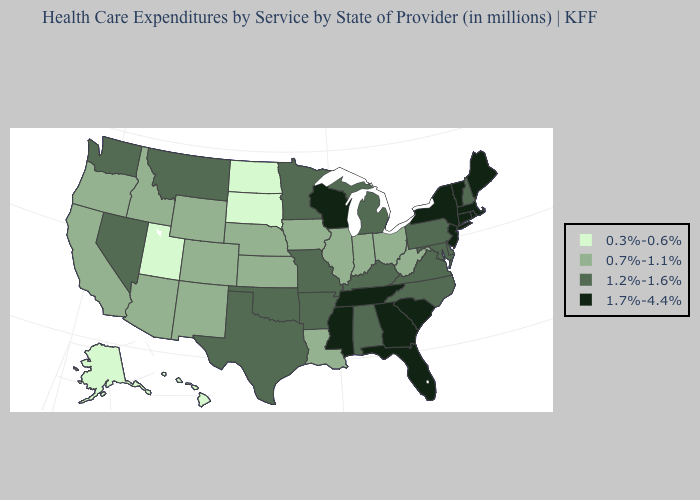Among the states that border Michigan , which have the lowest value?
Answer briefly. Indiana, Ohio. Name the states that have a value in the range 0.3%-0.6%?
Answer briefly. Alaska, Hawaii, North Dakota, South Dakota, Utah. Name the states that have a value in the range 0.7%-1.1%?
Quick response, please. Arizona, California, Colorado, Idaho, Illinois, Indiana, Iowa, Kansas, Louisiana, Nebraska, New Mexico, Ohio, Oregon, West Virginia, Wyoming. Name the states that have a value in the range 1.2%-1.6%?
Concise answer only. Alabama, Arkansas, Delaware, Kentucky, Maryland, Michigan, Minnesota, Missouri, Montana, Nevada, New Hampshire, North Carolina, Oklahoma, Pennsylvania, Texas, Virginia, Washington. What is the highest value in states that border Connecticut?
Answer briefly. 1.7%-4.4%. Does the map have missing data?
Concise answer only. No. Does Missouri have a lower value than New Hampshire?
Write a very short answer. No. What is the highest value in the USA?
Short answer required. 1.7%-4.4%. What is the value of Indiana?
Quick response, please. 0.7%-1.1%. Which states have the lowest value in the MidWest?
Answer briefly. North Dakota, South Dakota. What is the value of Nebraska?
Write a very short answer. 0.7%-1.1%. Name the states that have a value in the range 0.3%-0.6%?
Concise answer only. Alaska, Hawaii, North Dakota, South Dakota, Utah. Does the map have missing data?
Keep it brief. No. What is the lowest value in the USA?
Answer briefly. 0.3%-0.6%. 